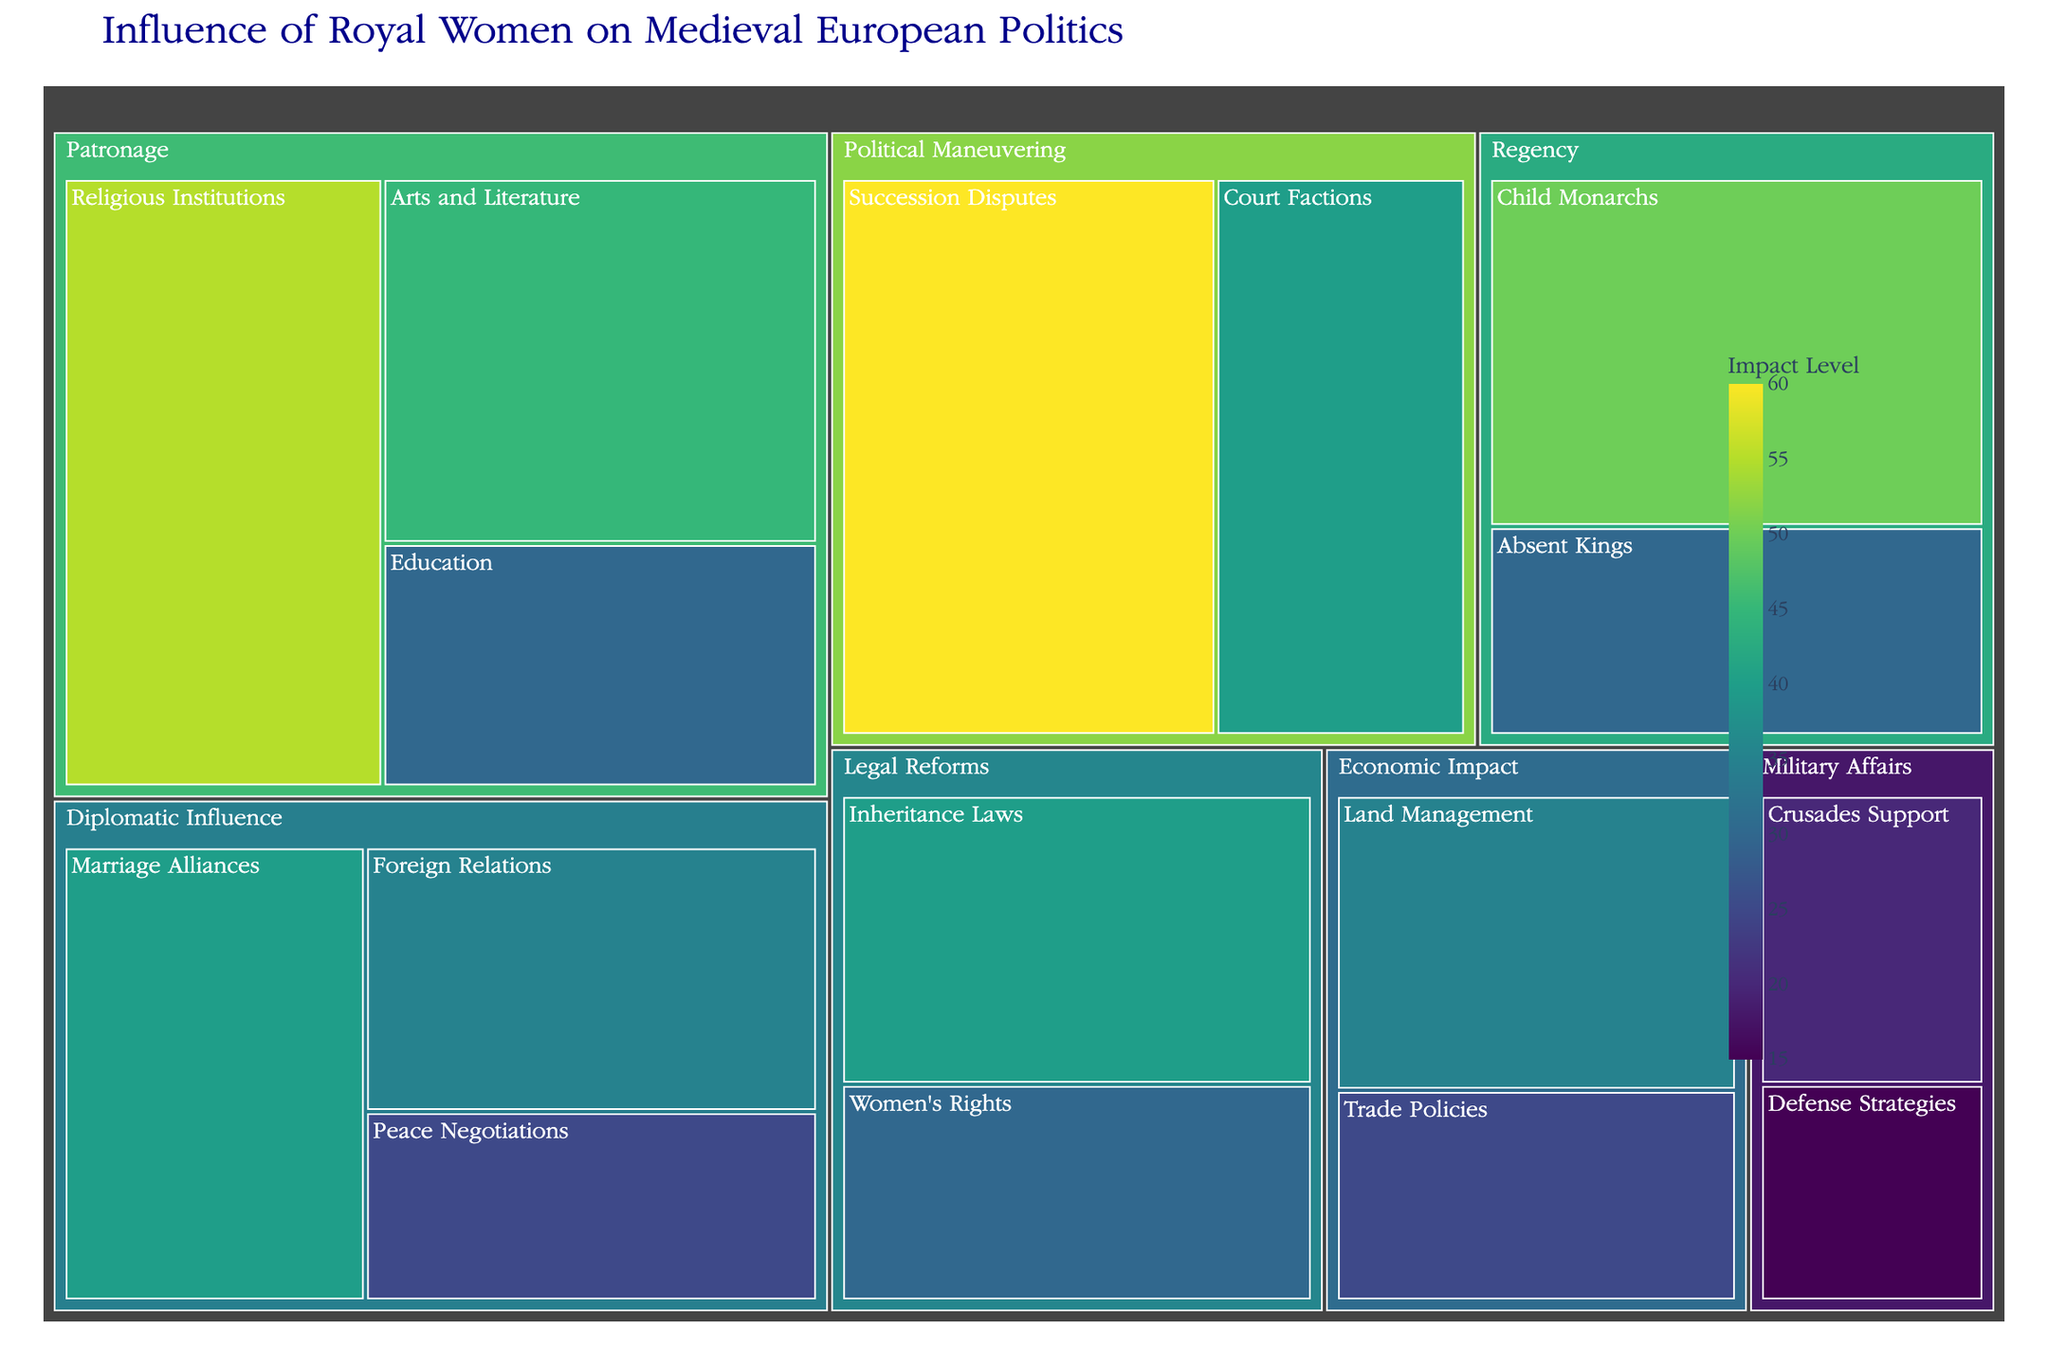What is the total value for the 'Patronage' category? Summing up the values of the subcategories under 'Patronage' (Arts and Literature: 45, Religious Institutions: 55, Education: 30) gives 45 + 55 + 30 = 130.
Answer: 130 Which subcategory has the highest impact under 'Political Maneuvering'? Comparing the values under 'Political Maneuvering' (Succession Disputes: 60, Court Factions: 40), we see that Succession Disputes has the highest value of 60.
Answer: Succession Disputes How does the total impact of 'Regency' compare to 'Military Affairs'? Summing up 'Regency' subcategories (Child Monarchs: 50, Absent Kings: 30) gives 50 + 30 = 80. Summing up 'Military Affairs' subcategories (Crusades Support: 20, Defense Strategies: 15) gives 20 + 15 = 35. Comparing both totals, 'Regency' (80) has a higher impact than 'Military Affairs' (35).
Answer: Regency is higher Which category has the smallest subcategory impact, and what is its value? Looking at all subcategories, Defense Strategies under 'Military Affairs' has the smallest value of 15.
Answer: Defense Strategies, 15 What is the combined impact of all 'Diplomatic Influence' subcategories? Summing up the values of the subcategories under 'Diplomatic Influence' (Marriage Alliances: 40, Peace Negotiations: 25, Foreign Relations: 35) gives 40 + 25 + 35 = 100.
Answer: 100 Compare the value of 'Women's Rights' under 'Legal Reforms' to 'Trade Policies' under 'Economic Impact'. 'Women's Rights' has a value of 30, while 'Trade Policies' has a value of 25. Therefore, 'Women's Rights' has a higher value.
Answer: Women's Rights > Trade Policies Which category has the highest overall impact, and what is the value? Adding the values for each category: Diplomatic Influence (100), Regency (80), Patronage (130), Political Maneuvering (100), Economic Impact (60), Military Affairs (35), Legal Reforms (70). 'Patronage' has the highest value at 130.
Answer: Patronage, 130 What is the value difference between 'Arts and Literature' under 'Patronage' and 'Child Monarchs' under 'Regency'? 'Arts and Literature' has a value of 45, and 'Child Monarchs' has a value of 50. The difference is 50 - 45 = 5.
Answer: 5 